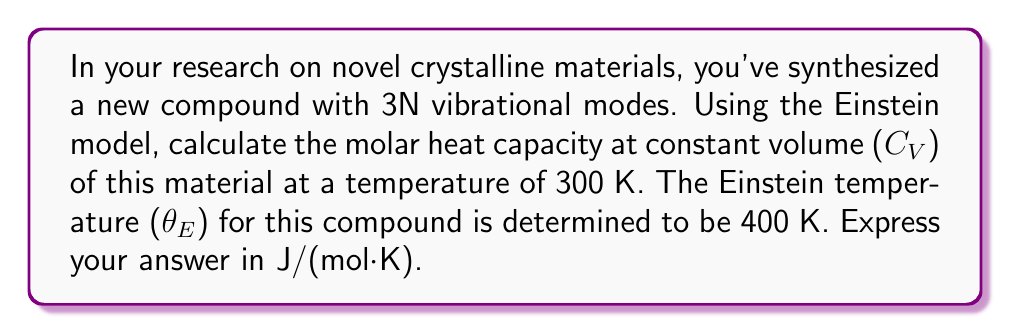What is the answer to this math problem? To solve this problem, we'll use the Einstein model for the heat capacity of a crystalline solid. The steps are as follows:

1) The Einstein model for molar heat capacity at constant volume is given by:

   $$C_V = 3R \left(\frac{\theta_E}{T}\right)^2 \frac{e^{\theta_E/T}}{(e^{\theta_E/T}-1)^2}$$

   where R is the gas constant, θ_E is the Einstein temperature, and T is the temperature.

2) We're given:
   - T = 300 K
   - θ_E = 400 K
   - R = 8.314 J/(mol·K)

3) Let's substitute these values into the equation:

   $$C_V = 3 \cdot 8.314 \left(\frac{400}{300}\right)^2 \frac{e^{400/300}}{(e^{400/300}-1)^2}$$

4) Simplify the fraction inside the parentheses:
   
   $$C_V = 3 \cdot 8.314 \left(\frac{4}{3}\right)^2 \frac{e^{4/3}}{(e^{4/3}-1)^2}$$

5) Calculate the exponential:
   
   $$e^{4/3} \approx 3.7956$$

6) Now we can compute the full expression:

   $$C_V = 3 \cdot 8.314 \cdot \left(\frac{4}{3}\right)^2 \cdot \frac{3.7956}{(3.7956-1)^2}$$

7) Simplify:
   
   $$C_V = 24.942 \cdot \frac{3.7956}{7.8033} \approx 23.69 \text{ J/(mol·K)}$$
Answer: 23.69 J/(mol·K) 